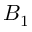<formula> <loc_0><loc_0><loc_500><loc_500>B _ { 1 }</formula> 